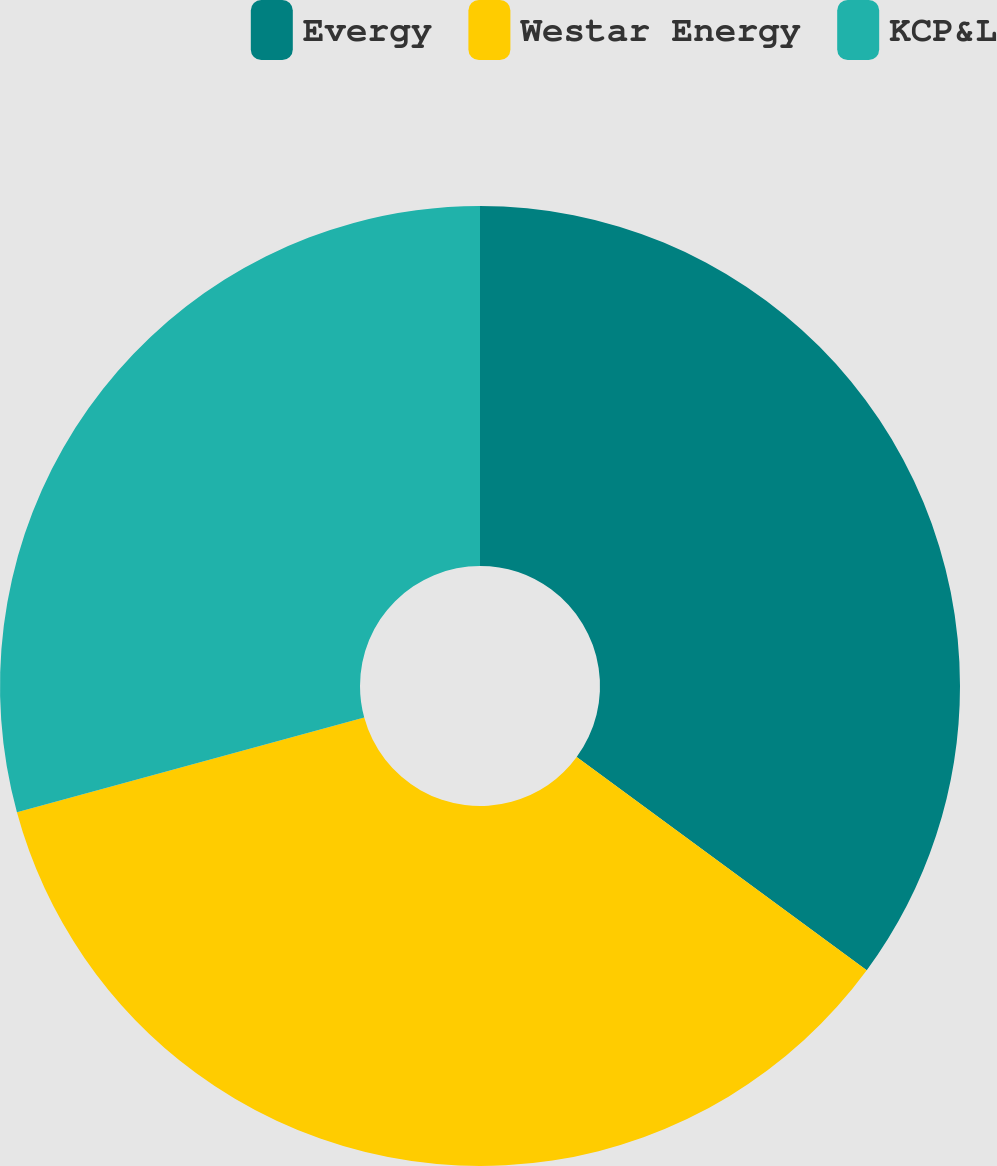<chart> <loc_0><loc_0><loc_500><loc_500><pie_chart><fcel>Evergy<fcel>Westar Energy<fcel>KCP&L<nl><fcel>35.09%<fcel>35.67%<fcel>29.24%<nl></chart> 